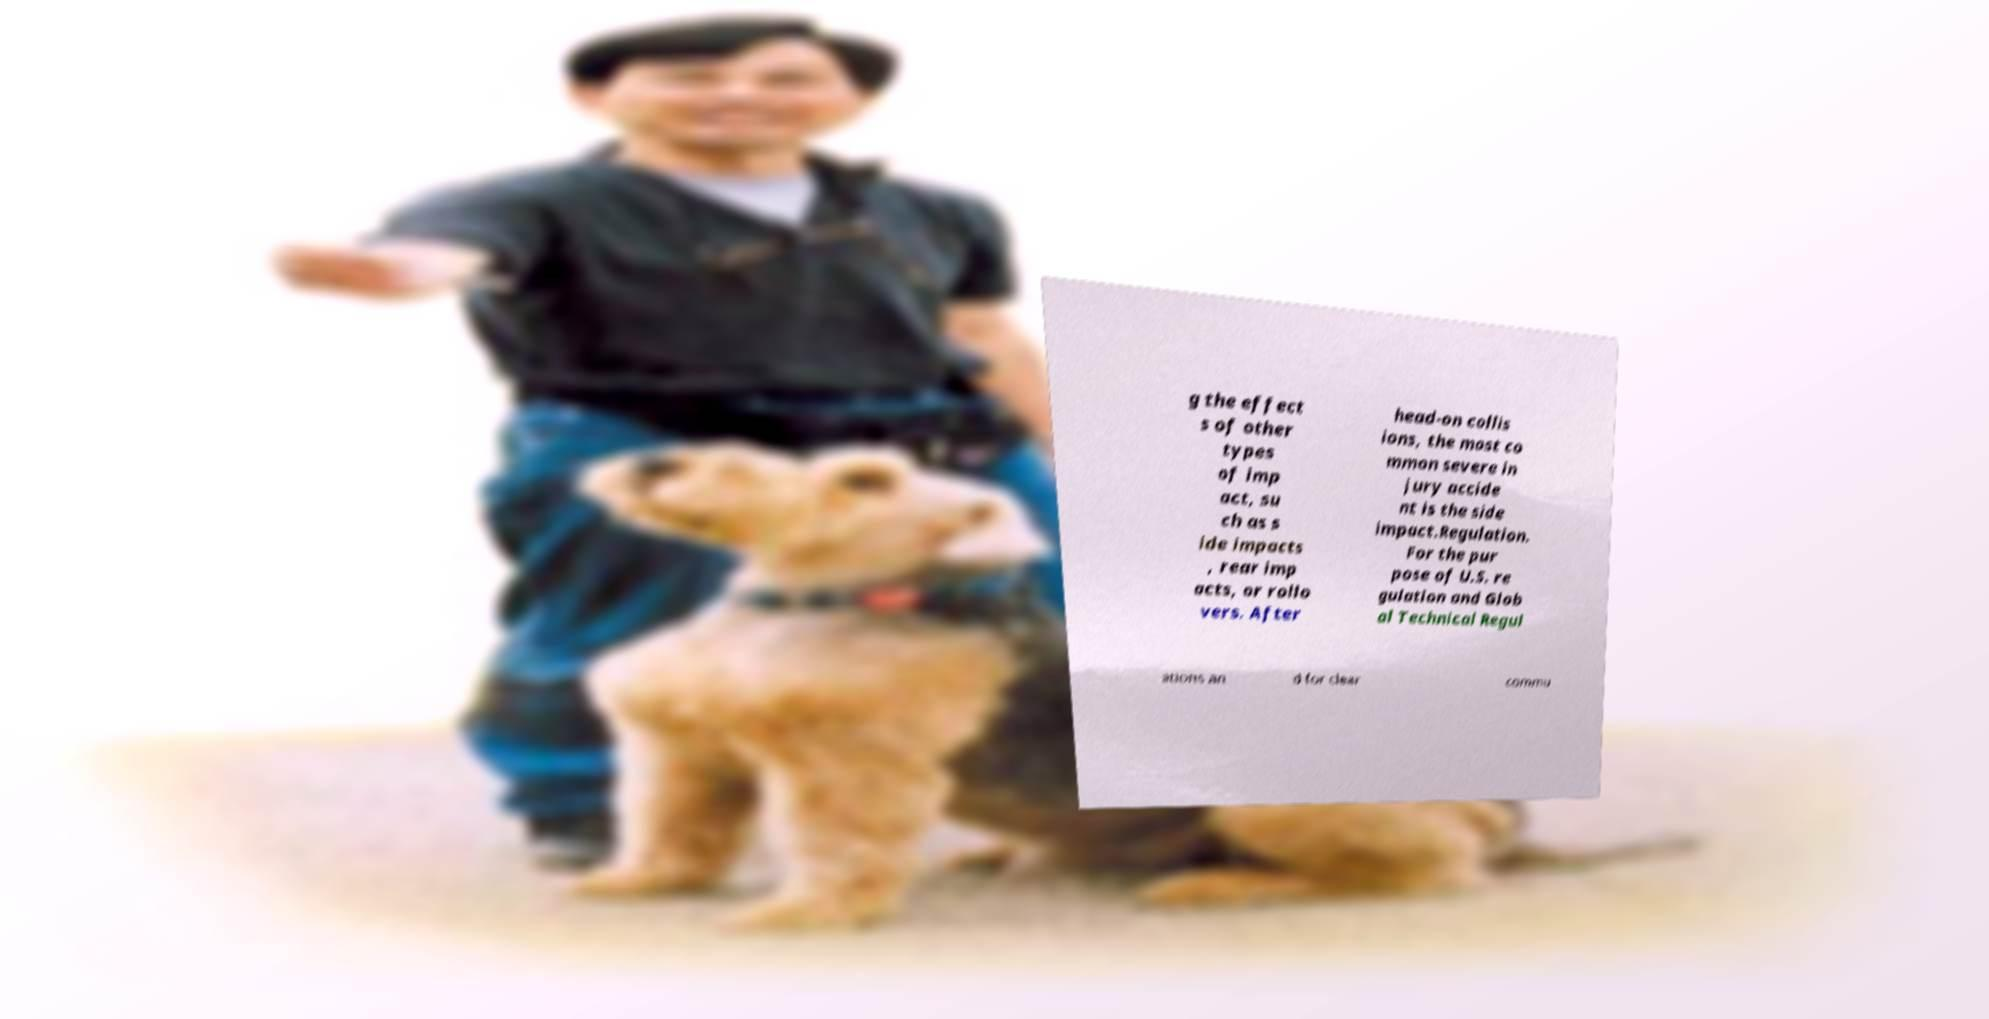Can you read and provide the text displayed in the image?This photo seems to have some interesting text. Can you extract and type it out for me? g the effect s of other types of imp act, su ch as s ide impacts , rear imp acts, or rollo vers. After head-on collis ions, the most co mmon severe in jury accide nt is the side impact.Regulation. For the pur pose of U.S. re gulation and Glob al Technical Regul ations an d for clear commu 